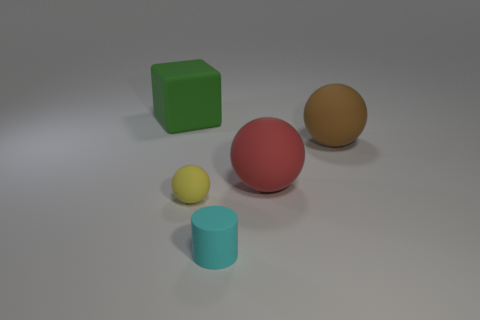Add 1 brown balls. How many objects exist? 6 Subtract all spheres. How many objects are left? 2 Subtract 0 gray cylinders. How many objects are left? 5 Subtract all large cyan rubber cubes. Subtract all large green rubber blocks. How many objects are left? 4 Add 1 small spheres. How many small spheres are left? 2 Add 5 small matte balls. How many small matte balls exist? 6 